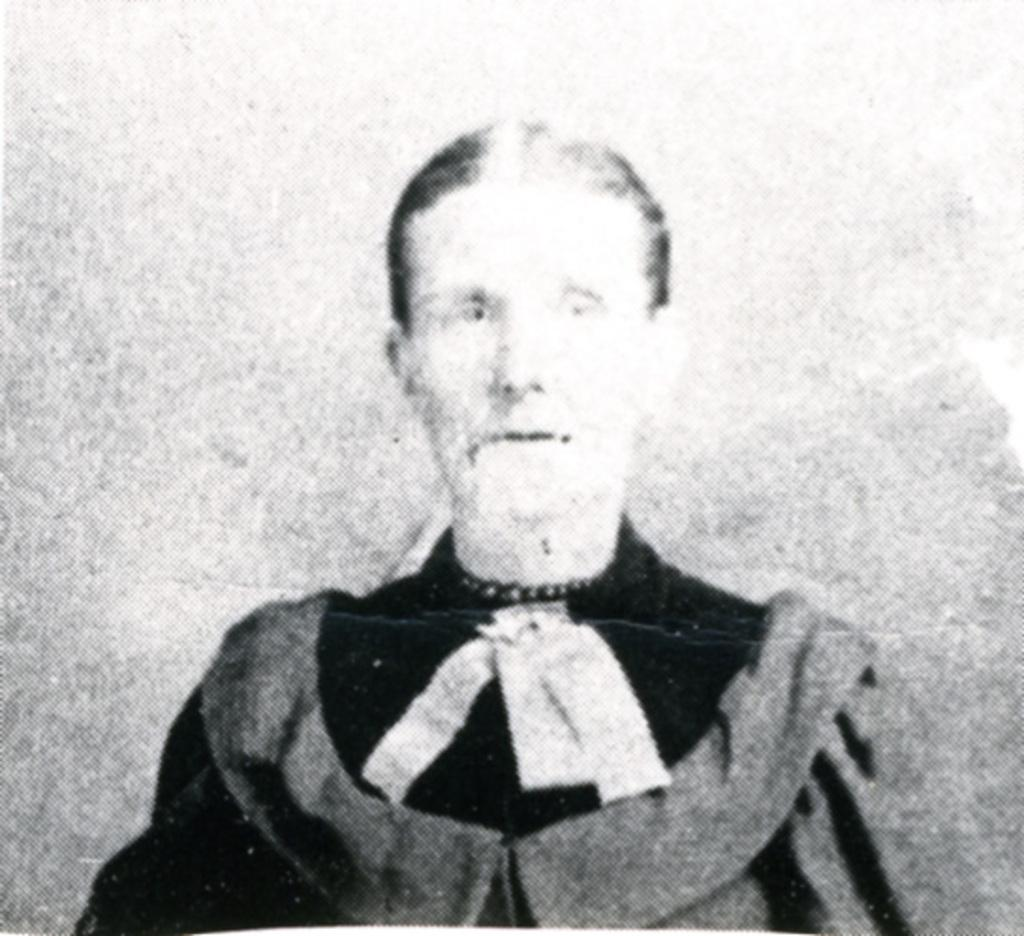How many people are in the image? There is one person in the image. What is the color scheme of the image? The image is black and white. What type of lamp is being used to distribute steam in the image? There is no lamp or steam present in the image; it is a black and white image of one person. 